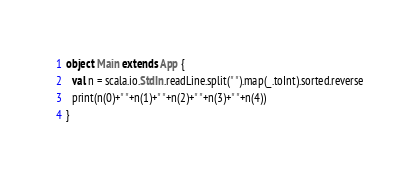Convert code to text. <code><loc_0><loc_0><loc_500><loc_500><_Scala_>object Main extends App {
  val n = scala.io.StdIn.readLine.split(" ").map(_.toInt).sorted.reverse
  print(n(0)+" "+n(1)+" "+n(2)+" "+n(3)+" "+n(4))
}</code> 